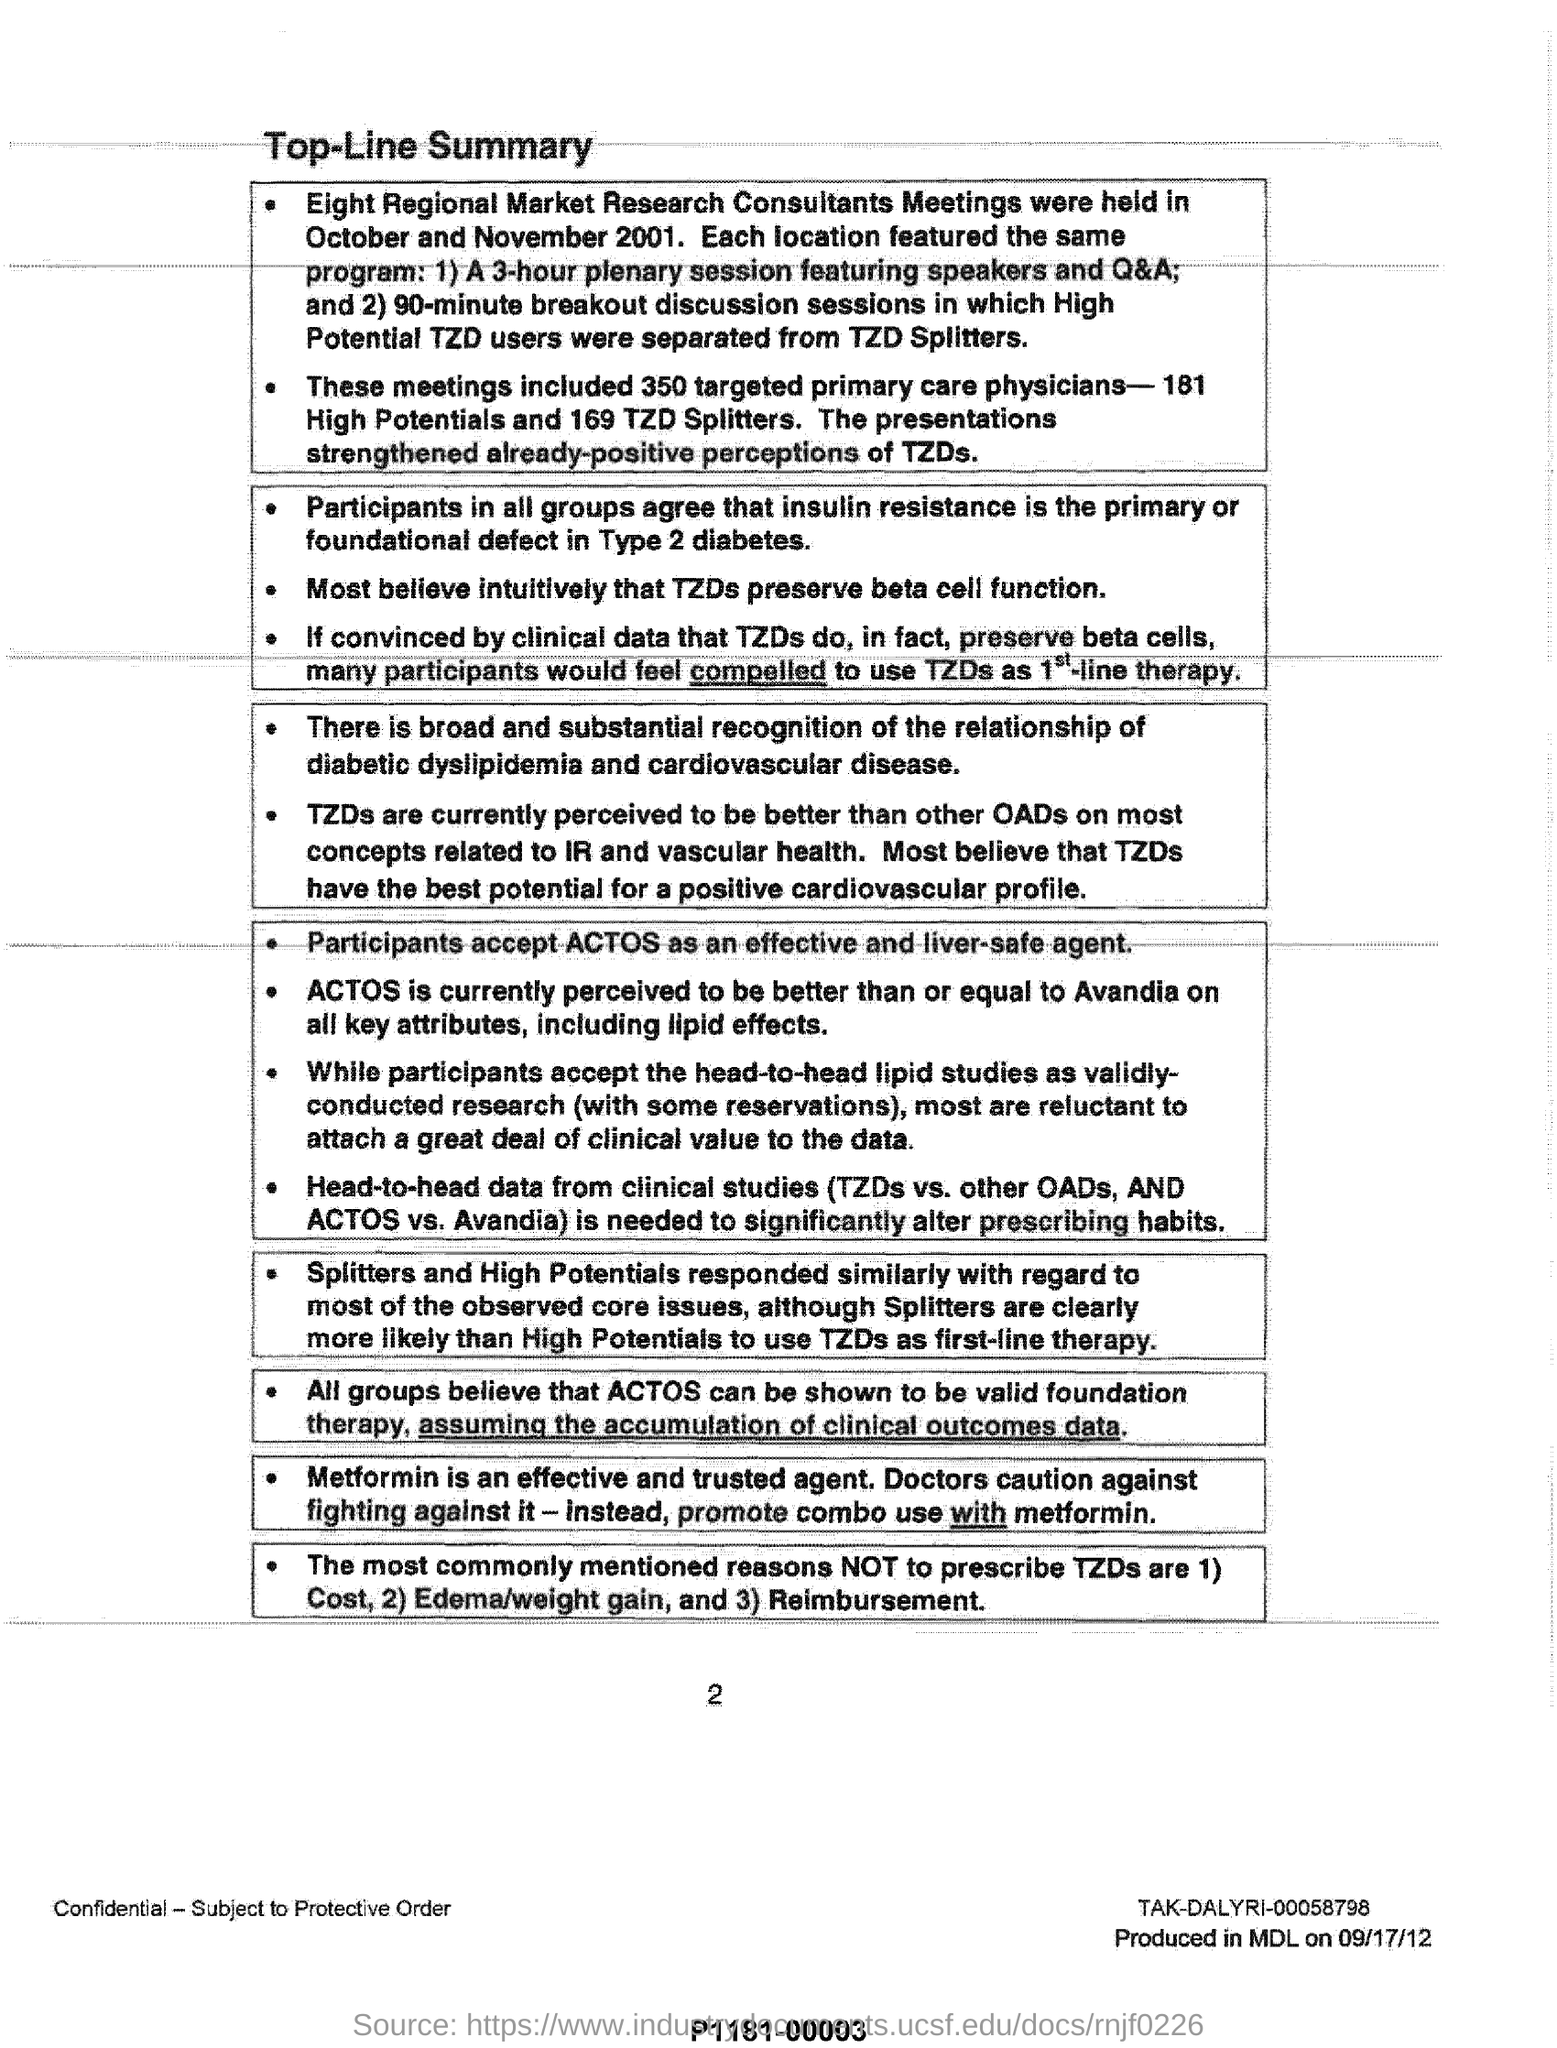How many targeted primary care physicians are included in these meetings ?
Your answer should be compact. 350. In which month and year eight regional market research consultants meetings were held ?
Make the answer very short. October and November 2001. Which is an effective and liver-safe agent accepted by the participants ?
Ensure brevity in your answer.  ACTOS. What is an effective and trusted agent ?
Your answer should be very brief. Metformin. What are the most commonly mentioned reasons not to prescribe tzd's ?
Offer a very short reply. 1) Cost, 2) Edema/weight gain, and 3) Reimbursement. 